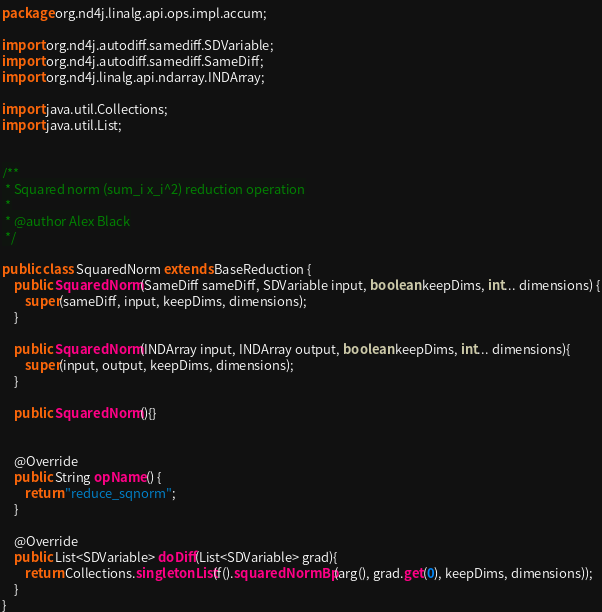<code> <loc_0><loc_0><loc_500><loc_500><_Java_>package org.nd4j.linalg.api.ops.impl.accum;

import org.nd4j.autodiff.samediff.SDVariable;
import org.nd4j.autodiff.samediff.SameDiff;
import org.nd4j.linalg.api.ndarray.INDArray;

import java.util.Collections;
import java.util.List;


/**
 * Squared norm (sum_i x_i^2) reduction operation
 *
 * @author Alex Black
 */

public class SquaredNorm extends BaseReduction {
    public SquaredNorm(SameDiff sameDiff, SDVariable input, boolean keepDims, int... dimensions) {
        super(sameDiff, input, keepDims, dimensions);
    }

    public SquaredNorm(INDArray input, INDArray output, boolean keepDims, int... dimensions){
        super(input, output, keepDims, dimensions);
    }

    public SquaredNorm(){}


    @Override
    public String opName() {
        return "reduce_sqnorm";
    }

    @Override
    public List<SDVariable> doDiff(List<SDVariable> grad){
        return Collections.singletonList(f().squaredNormBp(arg(), grad.get(0), keepDims, dimensions));
    }
}
</code> 